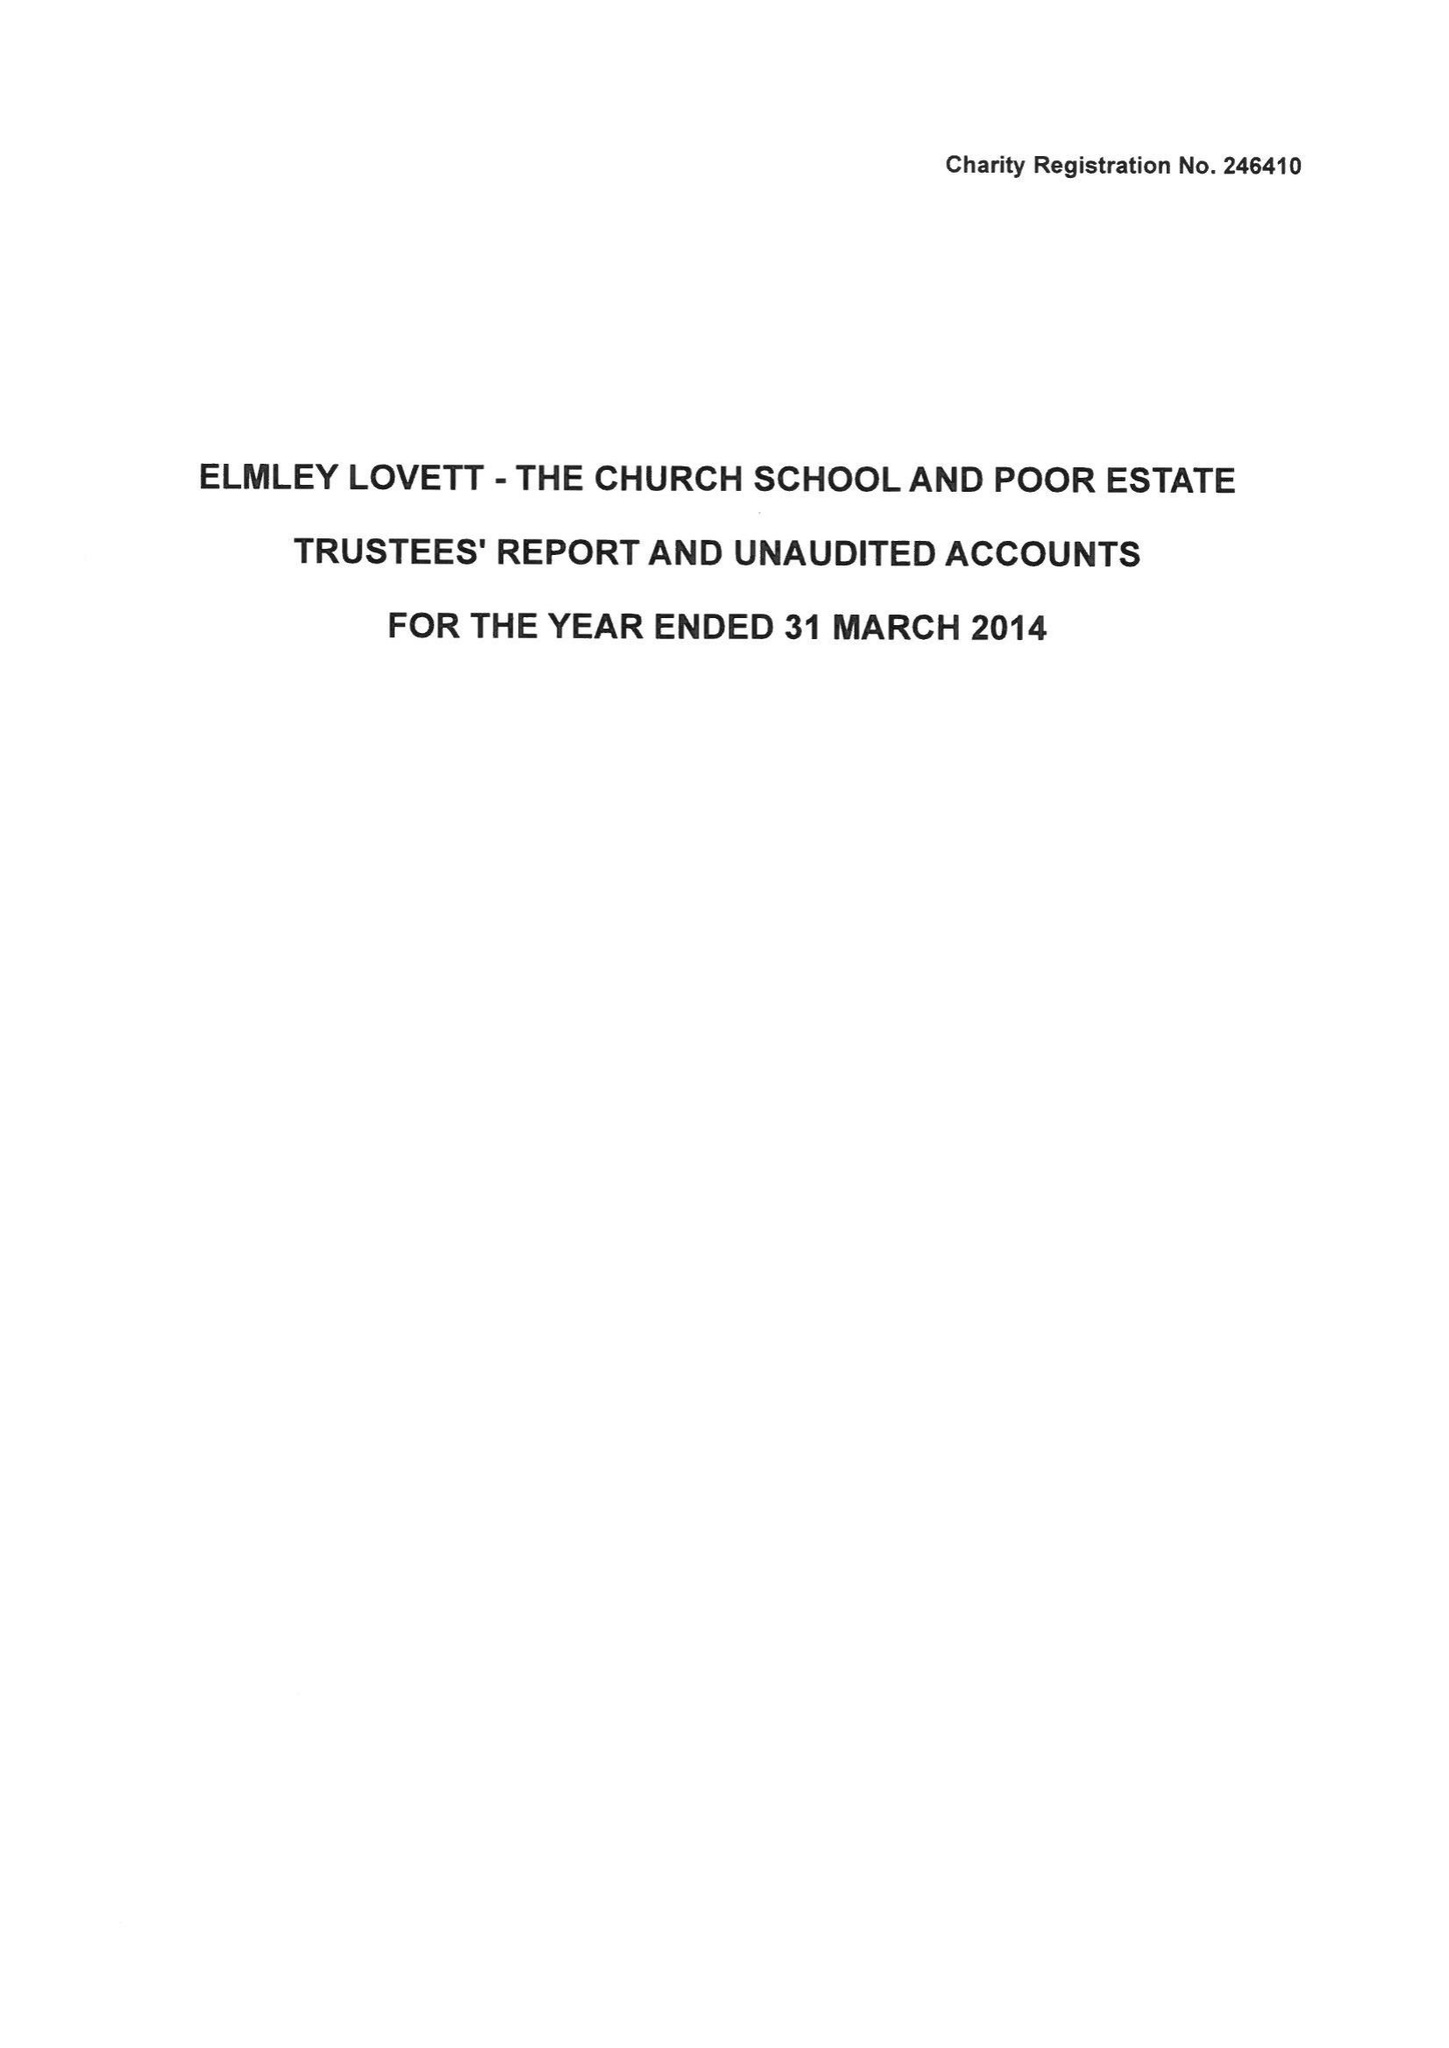What is the value for the spending_annually_in_british_pounds?
Answer the question using a single word or phrase. 10485.00 